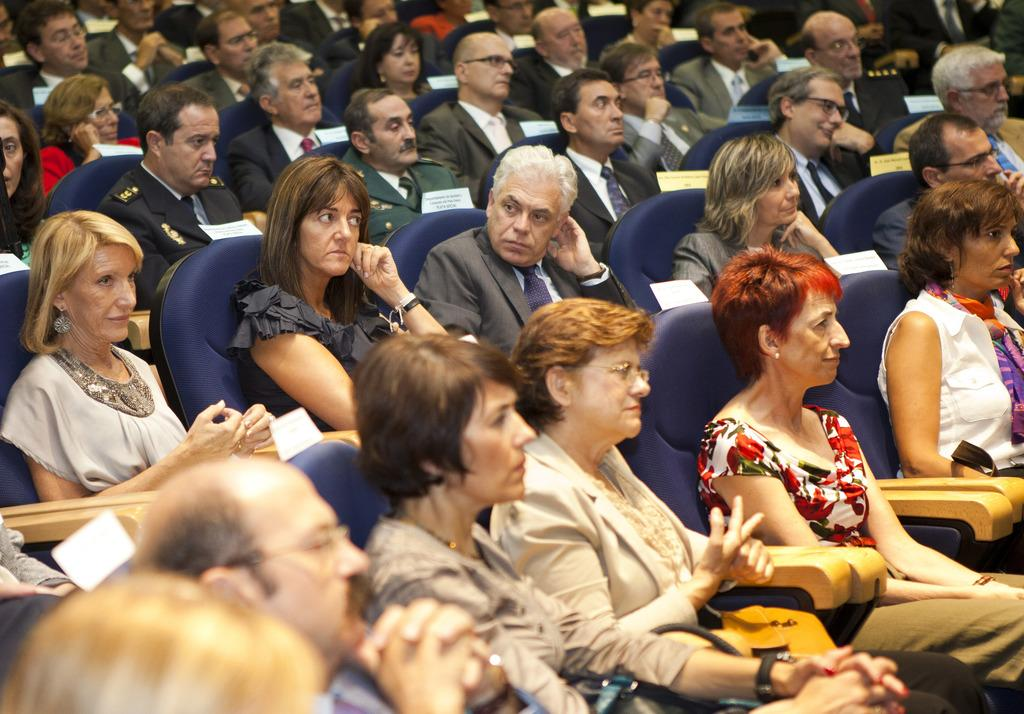What is the main subject of the image? The main subject of the image is a group of people. What are the people wearing in the image? The people are wearing dresses in the image. What are the people doing in the image? The people are sitting on chairs in the image. What can be seen in the background of the image? Papers with text can be seen in the background of the image. How are the papers arranged in the image? The papers are pasted on the chairs in the image. Can you see any trains in the image? No, there are no trains present in the image. Is there an umbrella visible in the image? No, there is no umbrella visible in the image. 